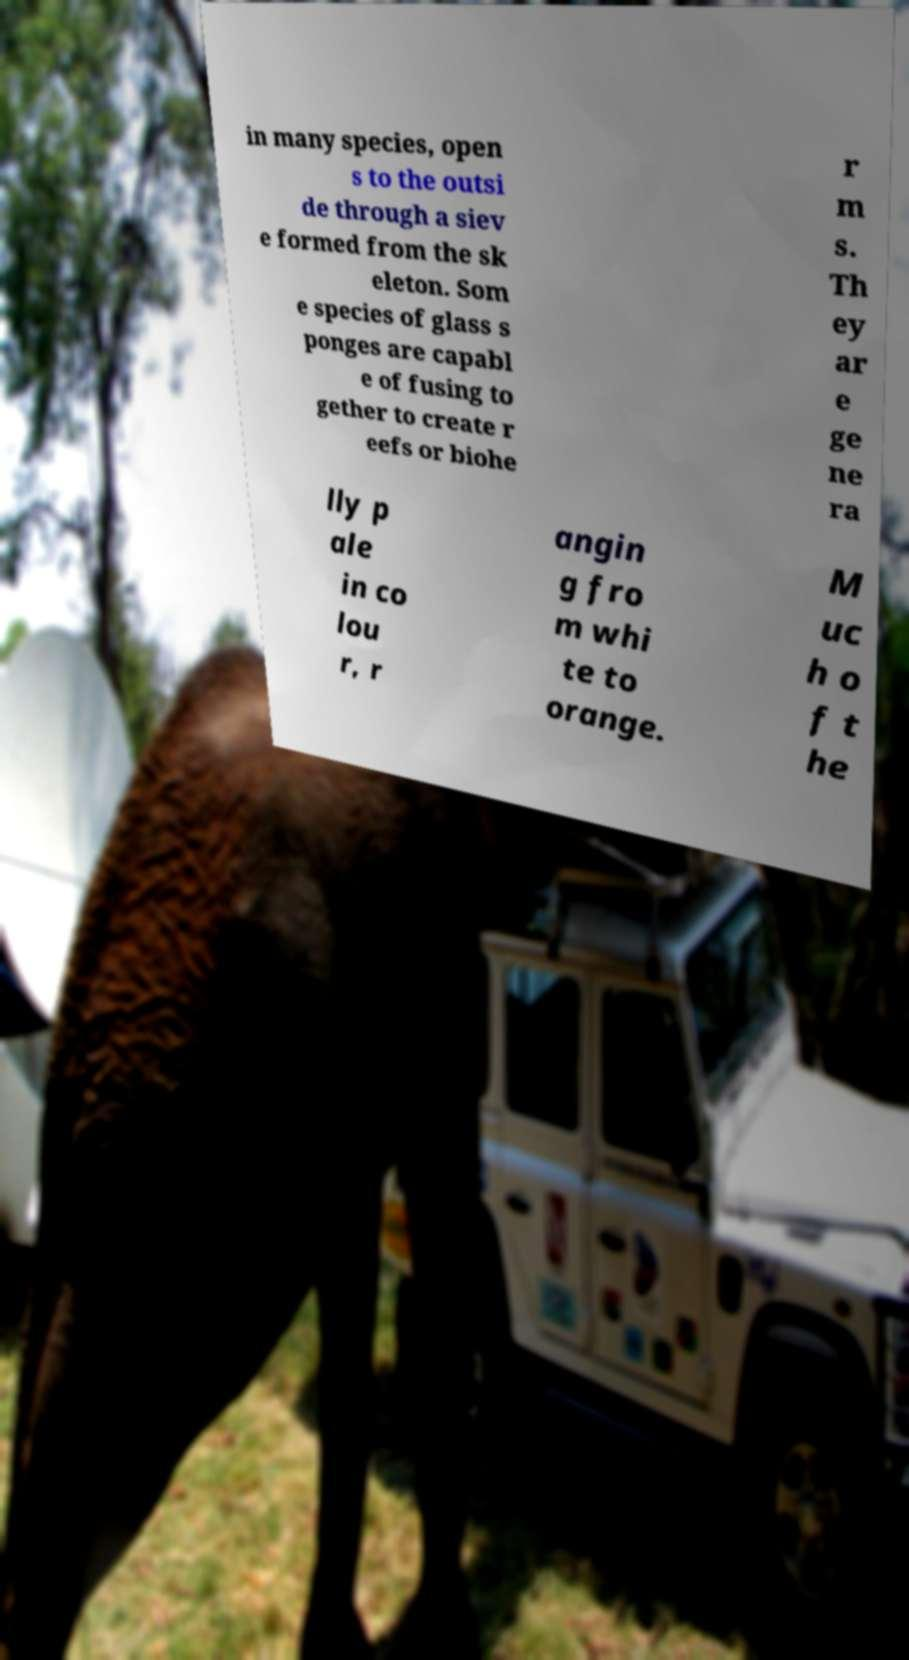Could you extract and type out the text from this image? in many species, open s to the outsi de through a siev e formed from the sk eleton. Som e species of glass s ponges are capabl e of fusing to gether to create r eefs or biohe r m s. Th ey ar e ge ne ra lly p ale in co lou r, r angin g fro m whi te to orange. M uc h o f t he 